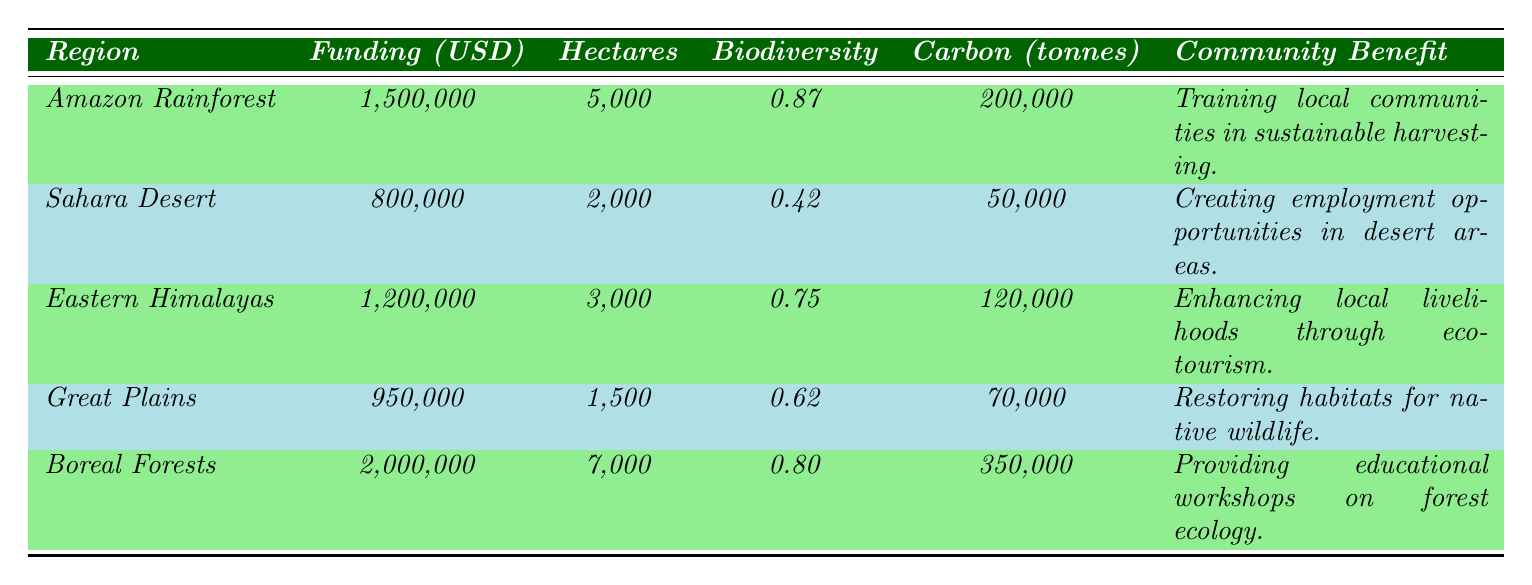What is the funding amount for the Amazon Restoration Project? The funding amount for the Amazon Restoration Project is listed in the table under the column "Funding (USD)" for the Amazon Rainforest row, which shows 1,500,000 USD.
Answer: 1,500,000 USD Which project has the highest biodiversity index? The biodiversity index values can be found in the biodiversity column. The Amazon Restoration Project has the highest index of 0.87.
Answer: Amazon Restoration Project How much carbon is sequestered by the Boreal Forests project? The carbon sequestration for the Boreal Forests project is found in the carbon column for that specific row, which indicates 350,000 tonnes.
Answer: 350,000 tonnes What is the total number of hectares reforested across all projects? To find the total hectares reforested, add the hectares for all projects: 5000 + 2000 + 3000 + 1500 + 7000 = 18500 hectares.
Answer: 18,500 hectares Is the community benefit for the Sahara Desert initiative focused on training? The community benefit for the Sahara Desert initiative is stated as "Creating employment opportunities in desert areas," which does not focus on training. Therefore, the answer is no.
Answer: No Which region had the least funding and what was it used for? The Sahara Desert had the least funding amount, which was 800,000 USD, and it was used for the Sahara Greening Initiative aimed at creating employment opportunities in desert areas.
Answer: Sahara Desert, 800,000 USD, employment opportunities What is the average biodiversity index across all projects? The biodiversity indices are 0.87, 0.42, 0.75, 0.62, and 0.80. First, sum these values: 0.87 + 0.42 + 0.75 + 0.62 + 0.80 = 3.46. Then, divide by the number of projects (5): 3.46 / 5 = 0.692.
Answer: 0.692 How much more funding did the Boreal Forests project receive compared to the Sahara Desert project? Find the funding amounts: Boreal Forests = 2,000,000 USD and Sahara Desert = 800,000 USD. Then, subtract: 2,000,000 - 800,000 = 1,200,000 USD.
Answer: 1,200,000 USD What type of community benefit is emphasized in the Great Plains project? In the Great Plains Reforestation Project, the community benefit is stated as "Restoring habitats for native wildlife," which emphasizes ecological restoration rather than direct social services.
Answer: Restoring habitats for native wildlife Which project sequesters the least carbon, and how much is it? The project that sequesters the least carbon is the Sahara Greening Initiative, with a carbon sequestration value of 50,000 tonnes, as listed in the respective row.
Answer: Sahara Greening Initiative, 50,000 tonnes 